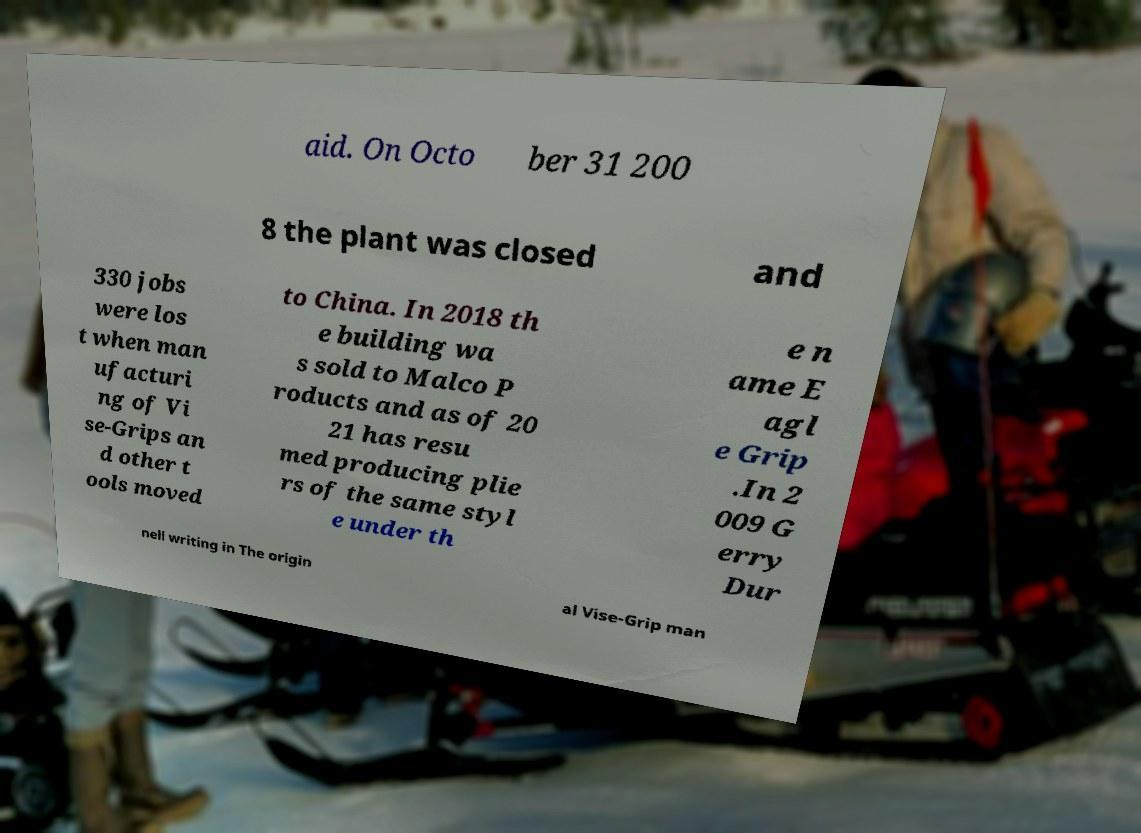Can you read and provide the text displayed in the image?This photo seems to have some interesting text. Can you extract and type it out for me? aid. On Octo ber 31 200 8 the plant was closed and 330 jobs were los t when man ufacturi ng of Vi se-Grips an d other t ools moved to China. In 2018 th e building wa s sold to Malco P roducts and as of 20 21 has resu med producing plie rs of the same styl e under th e n ame E agl e Grip .In 2 009 G erry Dur nell writing in The origin al Vise-Grip man 